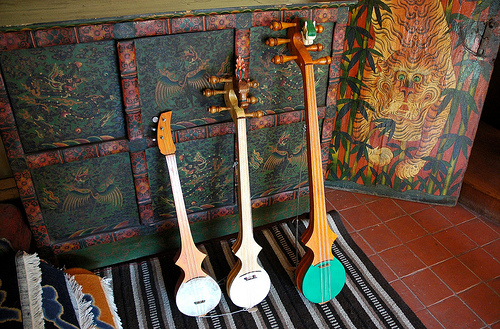<image>
Can you confirm if the green guitar is under the tiger painting? No. The green guitar is not positioned under the tiger painting. The vertical relationship between these objects is different. 